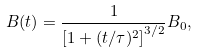Convert formula to latex. <formula><loc_0><loc_0><loc_500><loc_500>B ( t ) = \frac { 1 } { \left [ 1 + ( t / \tau ) ^ { 2 } \right ] ^ { 3 / 2 } } B _ { 0 } ,</formula> 